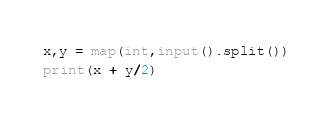Convert code to text. <code><loc_0><loc_0><loc_500><loc_500><_Python_>x,y = map(int,input().split())
print(x + y/2)</code> 